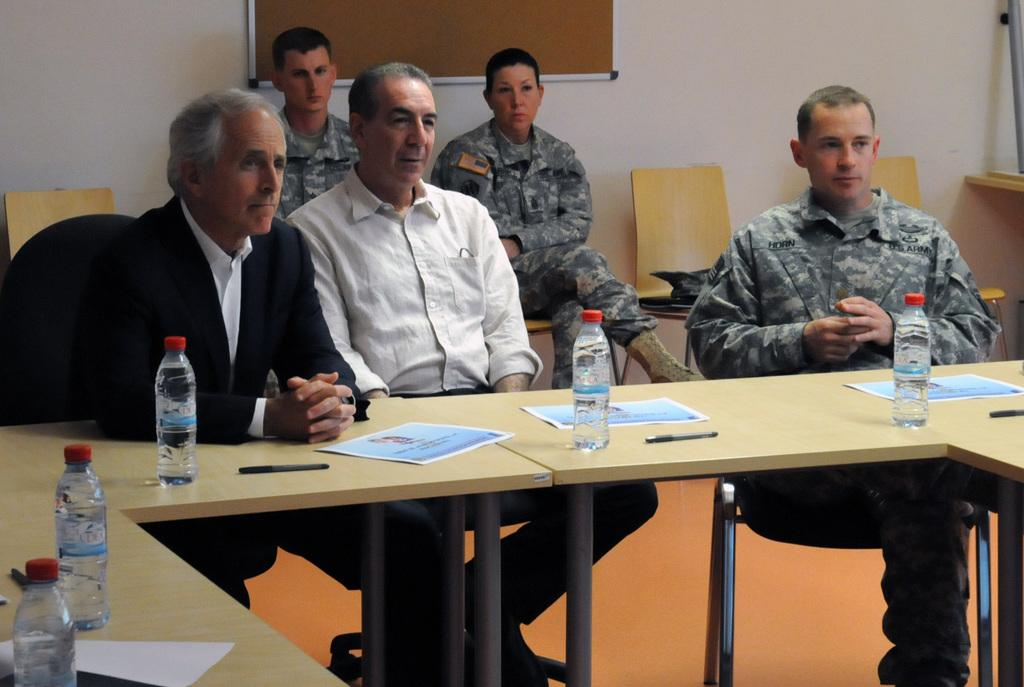How many people are present in the image? There are five people in the image. What are the people doing in the image? The people are sitting. What is in front of the people? There is a table in front of the people. What items can be seen on the table? There are water bottles, pens, and paper on the table. What type of locket is hanging from the tank in the image? There is no locket or tank present in the image. What is the ground like in the image? The provided facts do not mention the ground, so it cannot be determined from the image. 